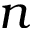<formula> <loc_0><loc_0><loc_500><loc_500>n</formula> 